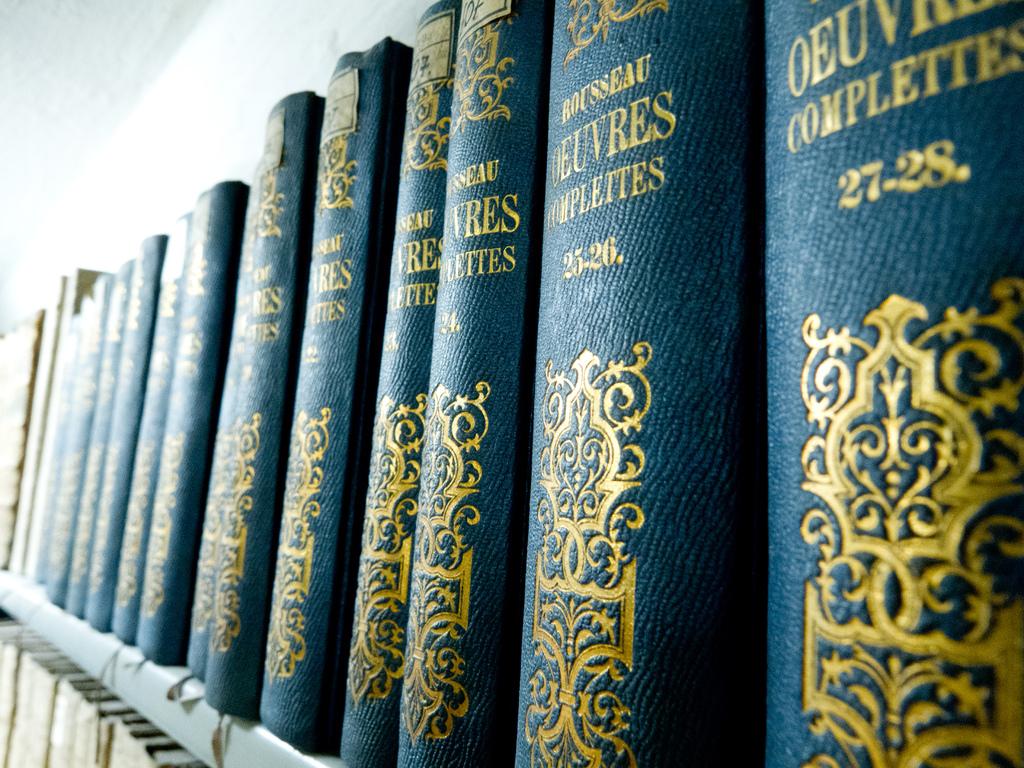What volume is closest?
Your answer should be compact. 27-28. What is the name of the set?
Your answer should be compact. Rousseau oevres complettes. 